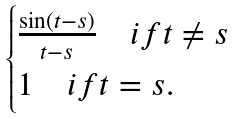Convert formula to latex. <formula><loc_0><loc_0><loc_500><loc_500>\begin{cases} \frac { \sin ( t - s ) } { t - s } \quad i f t \neq s \\ 1 \quad i f t = s . \end{cases}</formula> 